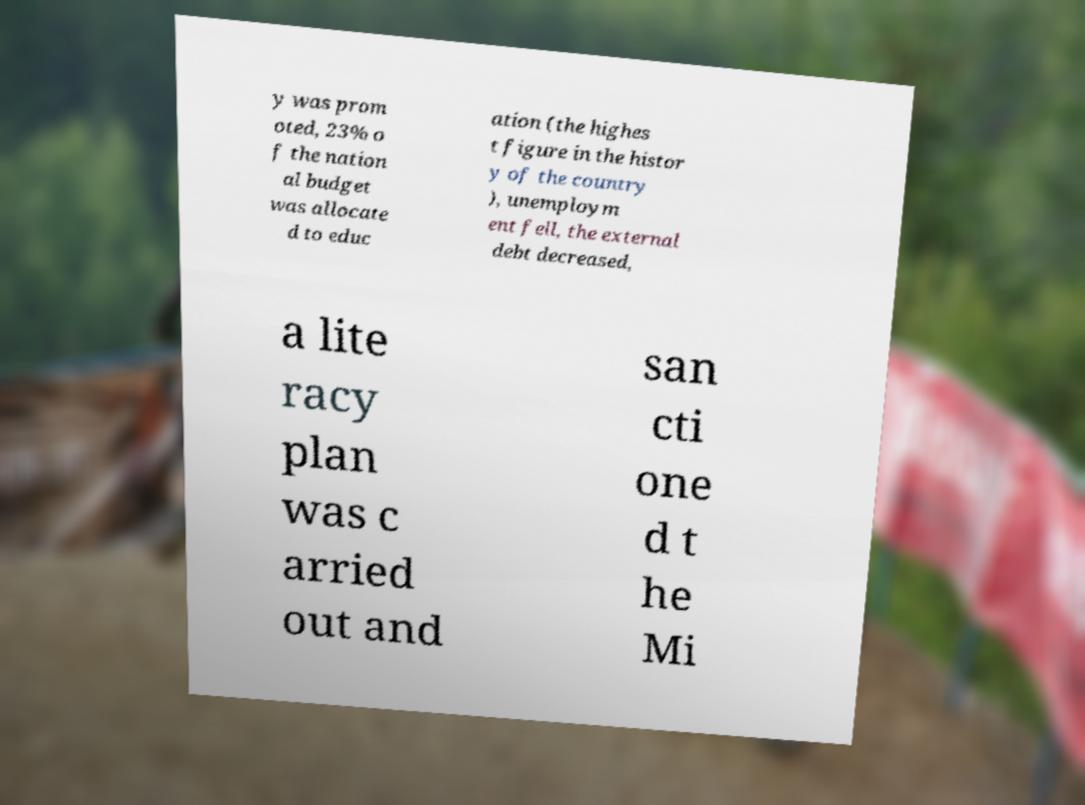I need the written content from this picture converted into text. Can you do that? y was prom oted, 23% o f the nation al budget was allocate d to educ ation (the highes t figure in the histor y of the country ), unemploym ent fell, the external debt decreased, a lite racy plan was c arried out and san cti one d t he Mi 